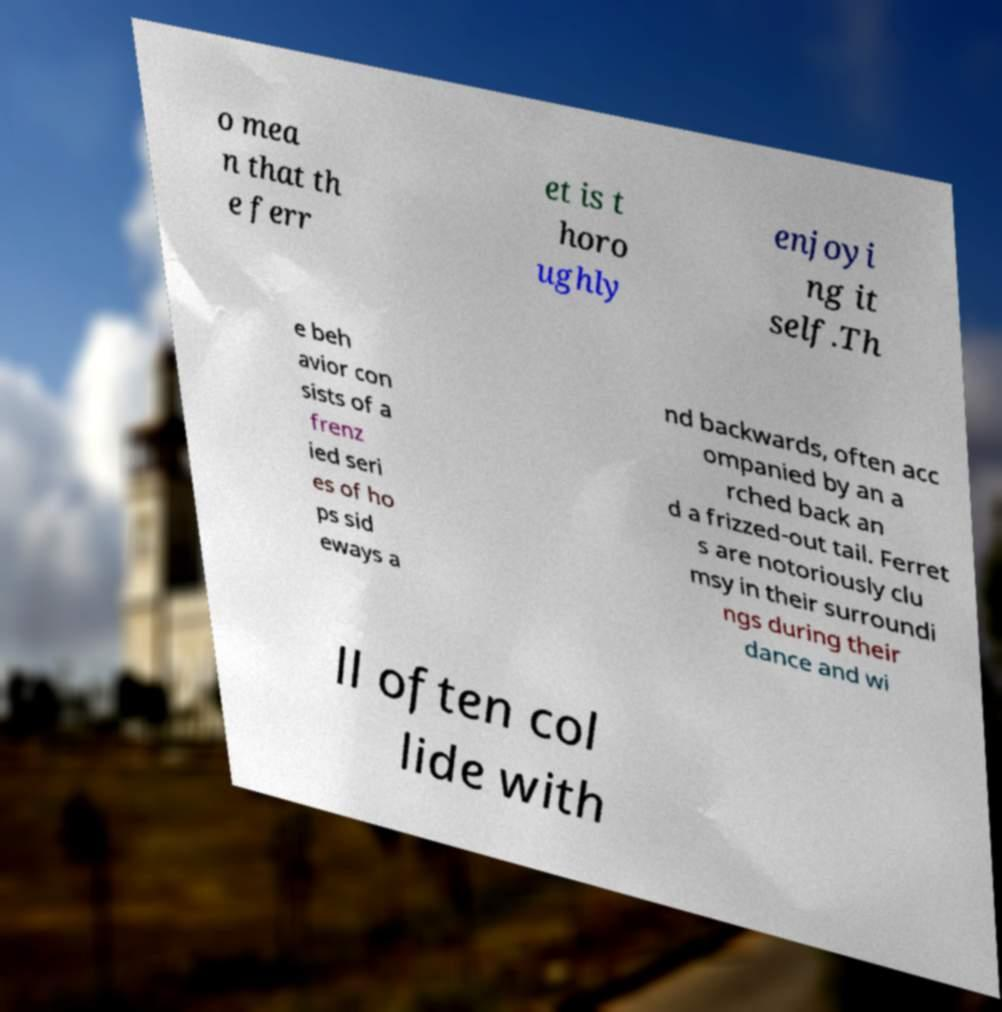Could you assist in decoding the text presented in this image and type it out clearly? o mea n that th e ferr et is t horo ughly enjoyi ng it self.Th e beh avior con sists of a frenz ied seri es of ho ps sid eways a nd backwards, often acc ompanied by an a rched back an d a frizzed-out tail. Ferret s are notoriously clu msy in their surroundi ngs during their dance and wi ll often col lide with 